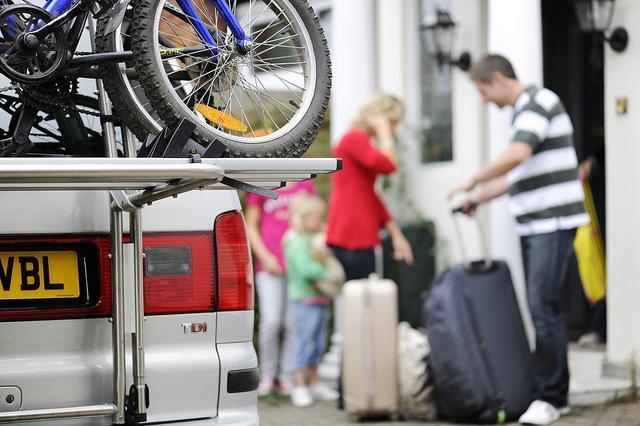How many roller suitcases do you see?
Give a very brief answer. 2. How many suitcases are there?
Give a very brief answer. 2. How many people can you see?
Give a very brief answer. 4. How many bicycles are there?
Give a very brief answer. 2. How many glasses are full of orange juice?
Give a very brief answer. 0. 